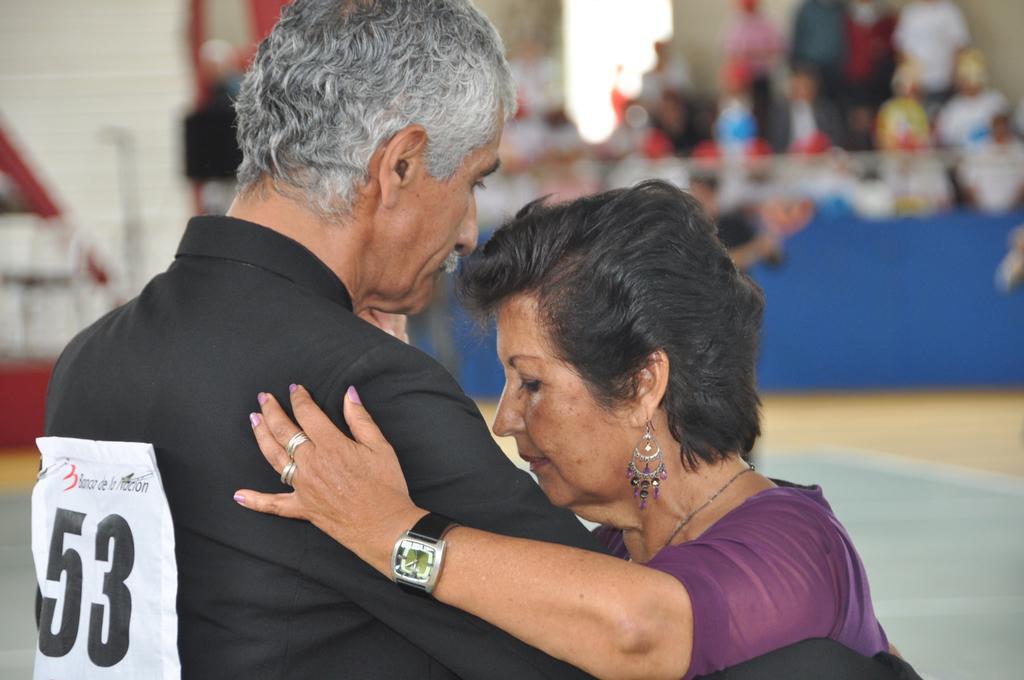Describe this image in one or two sentences. In this picture there is a man with black shirt is holding the woman. At the back there are group of people behind the board. At the bottom there is a floor. 